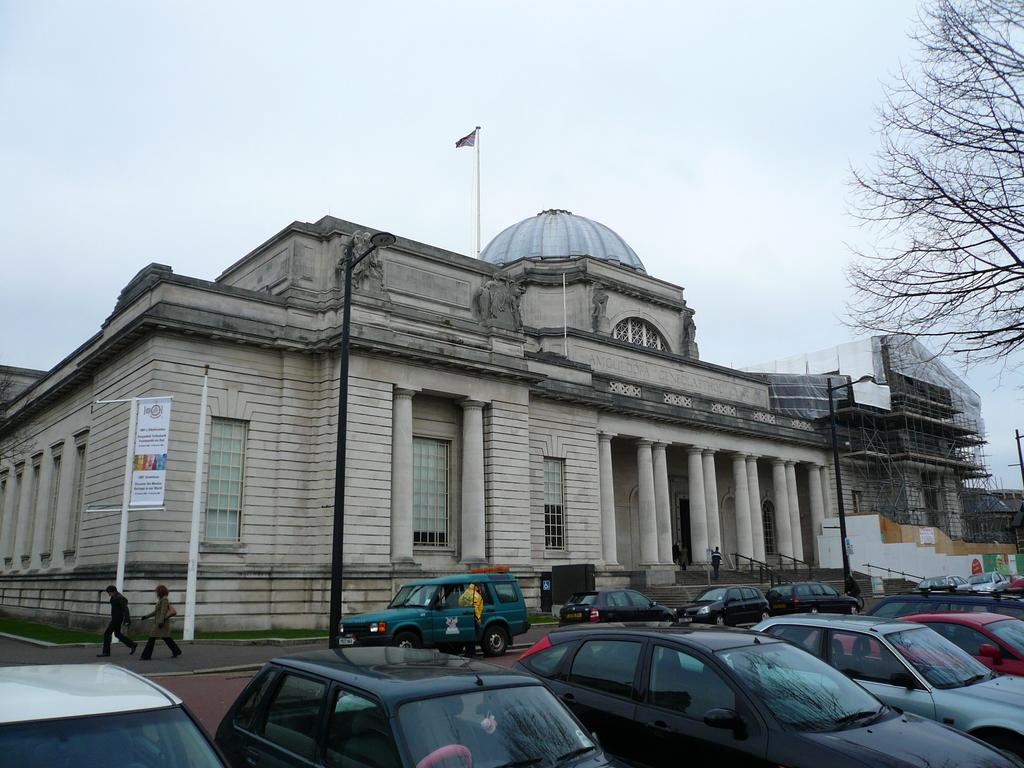What type of structures can be seen in the image? There are buildings in the image. What is attached to the flag post? There is a flag in the image. What is displayed on the flag post? There is an advertisement in the image. What type of vertical structures are present in the image? There are street poles in the image. What type of lighting is present in the image? There are street lights in the image. Are there any people visible in the image? Yes, there are persons on the road in the image. What type of surface is visible in the image? There is ground visible in the image. What part of the natural environment is visible in the image? There is sky visible in the image. What type of vehicles can be seen parked on the road? There are motor vehicles parked on the road in the image. Where is the cake located in the image? There is no cake present in the image. What type of room can be seen in the image? There is no room present in the image; it is an outdoor scene. 